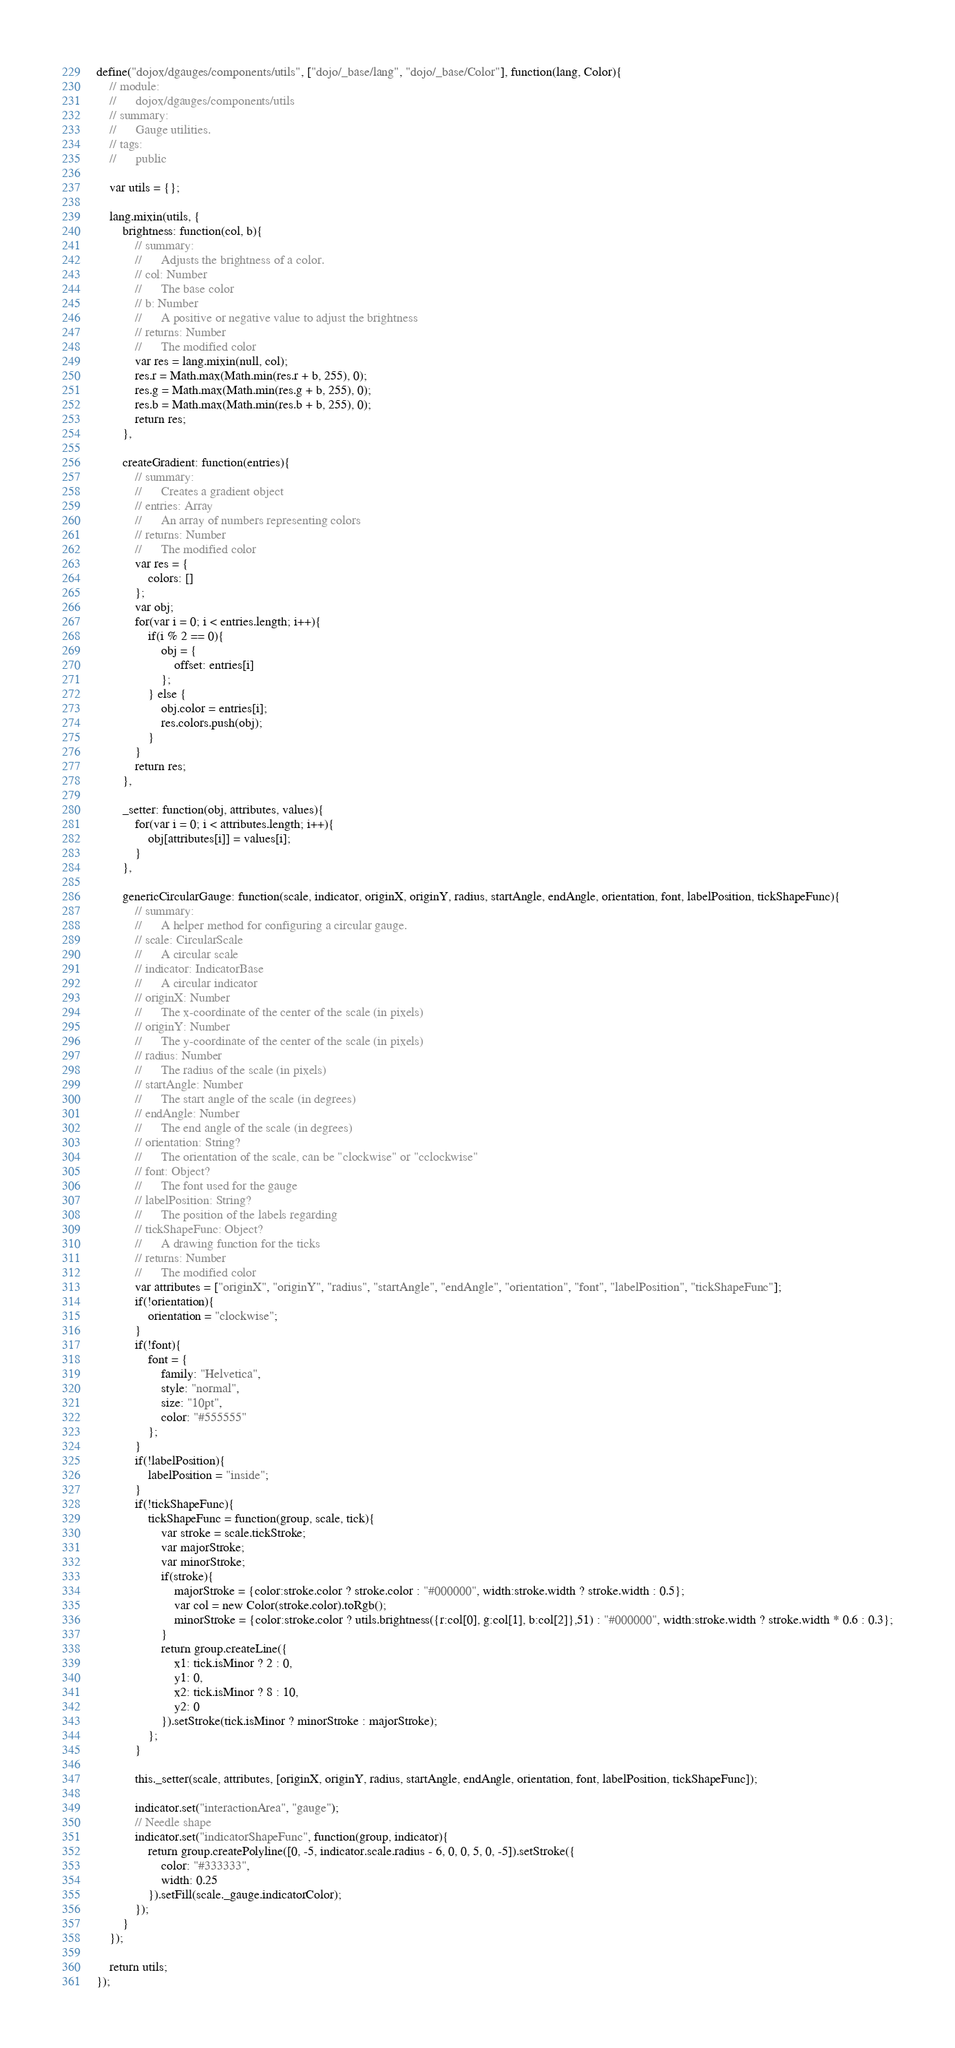<code> <loc_0><loc_0><loc_500><loc_500><_JavaScript_>define("dojox/dgauges/components/utils", ["dojo/_base/lang", "dojo/_base/Color"], function(lang, Color){
	// module:
	//		dojox/dgauges/components/utils
	// summary:
	//		Gauge utilities.
	// tags:
	//		public

	var utils = {};

	lang.mixin(utils, {
		brightness: function(col, b){
			// summary:
			//		Adjusts the brightness of a color.
			// col: Number
			//		The base color
			// b: Number
			//		A positive or negative value to adjust the brightness
			// returns: Number
			//		The modified color			
			var res = lang.mixin(null, col);
			res.r = Math.max(Math.min(res.r + b, 255), 0);
			res.g = Math.max(Math.min(res.g + b, 255), 0);
			res.b = Math.max(Math.min(res.b + b, 255), 0);
			return res;
		},
		
		createGradient: function(entries){
			// summary:
			//		Creates a gradient object
			// entries: Array
			//		An array of numbers representing colors
			// returns: Number
			//		The modified color			
			var res = {
				colors: []
			};
			var obj;
			for(var i = 0; i < entries.length; i++){
				if(i % 2 == 0){
					obj = {
						offset: entries[i]
					};
				} else {
					obj.color = entries[i];
					res.colors.push(obj);
				}
			}
			return res;
		},
		
		_setter: function(obj, attributes, values){
			for(var i = 0; i < attributes.length; i++){
				obj[attributes[i]] = values[i];
			}
		},
		
		genericCircularGauge: function(scale, indicator, originX, originY, radius, startAngle, endAngle, orientation, font, labelPosition, tickShapeFunc){
			// summary:
			//		A helper method for configuring a circular gauge.
			// scale: CircularScale
			//		A circular scale
			// indicator: IndicatorBase
			//		A circular indicator
			// originX: Number
			//		The x-coordinate of the center of the scale (in pixels) 
			// originY: Number
			//		The y-coordinate of the center of the scale (in pixels)
			// radius: Number
			//		The radius of the scale (in pixels)
			// startAngle: Number
			//		The start angle of the scale (in degrees)
			// endAngle: Number
			//		The end angle of the scale (in degrees)
			// orientation: String?
			//		The orientation of the scale, can be "clockwise" or "cclockwise"
			// font: Object?
			//		The font used for the gauge
			// labelPosition: String?
			//		The position of the labels regarding   
			// tickShapeFunc: Object?
			//		A drawing function for the ticks
			// returns: Number
			//		The modified color	
			var attributes = ["originX", "originY", "radius", "startAngle", "endAngle", "orientation", "font", "labelPosition", "tickShapeFunc"];
			if(!orientation){
				orientation = "clockwise";
			}
			if(!font){
				font = {
					family: "Helvetica",
					style: "normal",
					size: "10pt",
					color: "#555555"
				};
			}
			if(!labelPosition){
				labelPosition = "inside";
			}
			if(!tickShapeFunc){
				tickShapeFunc = function(group, scale, tick){
					var stroke = scale.tickStroke;
					var majorStroke;
					var minorStroke;
					if(stroke){
						majorStroke = {color:stroke.color ? stroke.color : "#000000", width:stroke.width ? stroke.width : 0.5};
						var col = new Color(stroke.color).toRgb();
						minorStroke = {color:stroke.color ? utils.brightness({r:col[0], g:col[1], b:col[2]},51) : "#000000", width:stroke.width ? stroke.width * 0.6 : 0.3};
					}
					return group.createLine({
						x1: tick.isMinor ? 2 : 0,
						y1: 0,
						x2: tick.isMinor ? 8 : 10,
						y2: 0
					}).setStroke(tick.isMinor ? minorStroke : majorStroke);
				};
			}
			
			this._setter(scale, attributes, [originX, originY, radius, startAngle, endAngle, orientation, font, labelPosition, tickShapeFunc]);
			
			indicator.set("interactionArea", "gauge");
			// Needle shape
			indicator.set("indicatorShapeFunc", function(group, indicator){
				return group.createPolyline([0, -5, indicator.scale.radius - 6, 0, 0, 5, 0, -5]).setStroke({
					color: "#333333",
					width: 0.25
				}).setFill(scale._gauge.indicatorColor);
			});
		}
	});

	return utils;
});
</code> 